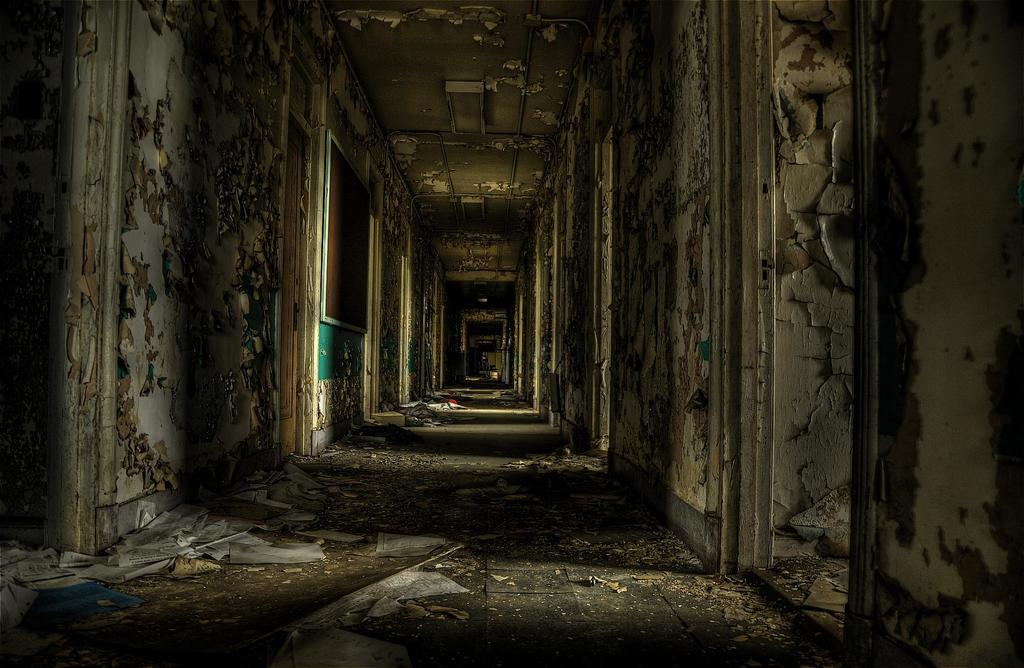What type of structure is in the image? There is an old building in the image. What is on the floor inside the building? Papers are on the floor in the image. Where is the board located in the building? The board is on the left side wall of the building in the image. What type of animal can be seen making a decision in the image? There is no animal present in the image, and therefore no decision-making can be observed. 